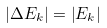Convert formula to latex. <formula><loc_0><loc_0><loc_500><loc_500>\left | { \Delta E _ { k } } \right | = \left | { E _ { k } } \right |</formula> 